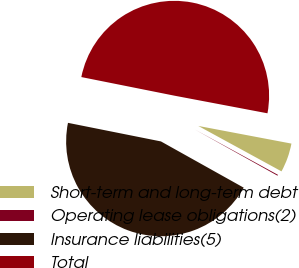<chart> <loc_0><loc_0><loc_500><loc_500><pie_chart><fcel>Short-term and long-term debt<fcel>Operating lease obligations(2)<fcel>Insurance liabilities(5)<fcel>Total<nl><fcel>4.97%<fcel>0.16%<fcel>45.03%<fcel>49.84%<nl></chart> 